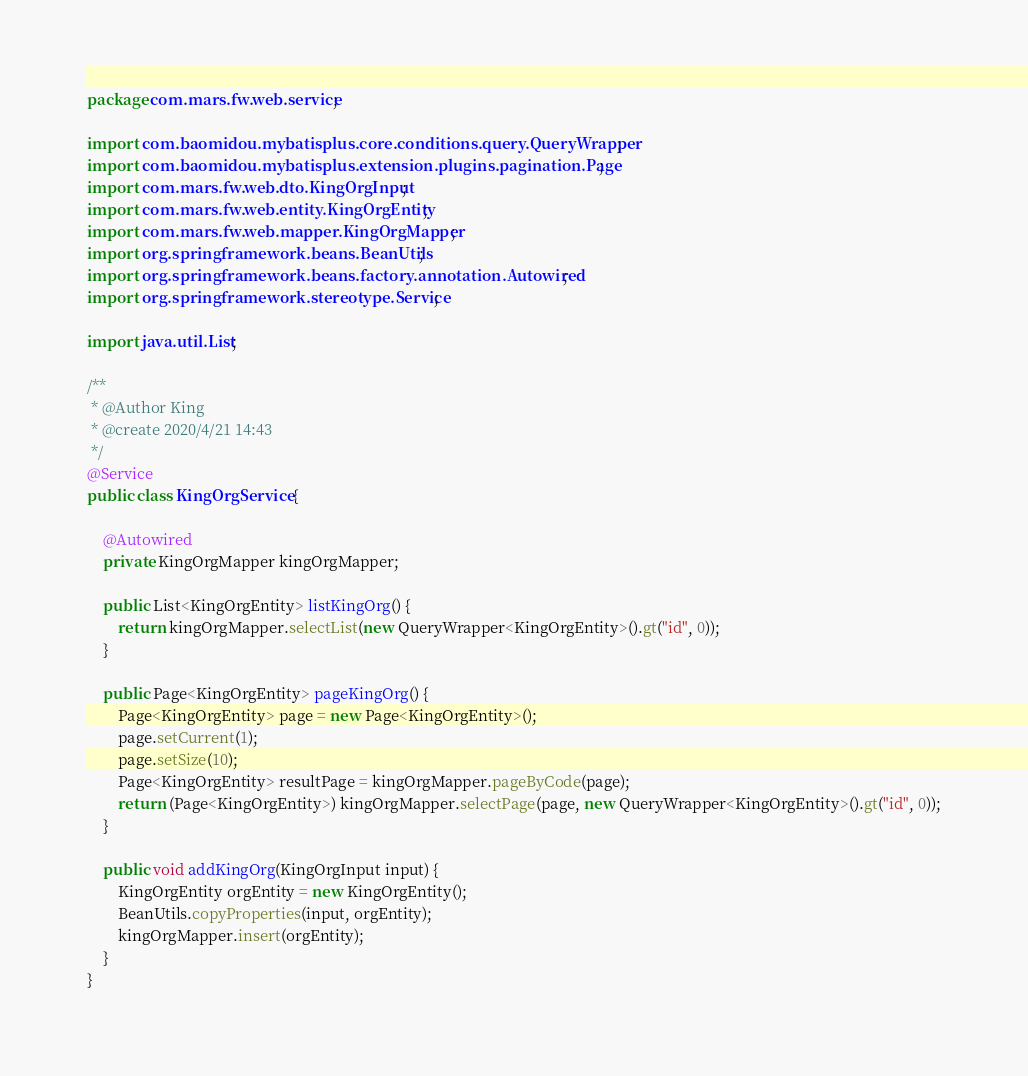Convert code to text. <code><loc_0><loc_0><loc_500><loc_500><_Java_>package com.mars.fw.web.service;

import com.baomidou.mybatisplus.core.conditions.query.QueryWrapper;
import com.baomidou.mybatisplus.extension.plugins.pagination.Page;
import com.mars.fw.web.dto.KingOrgInput;
import com.mars.fw.web.entity.KingOrgEntity;
import com.mars.fw.web.mapper.KingOrgMapper;
import org.springframework.beans.BeanUtils;
import org.springframework.beans.factory.annotation.Autowired;
import org.springframework.stereotype.Service;

import java.util.List;

/**
 * @Author King
 * @create 2020/4/21 14:43
 */
@Service
public class KingOrgService {

    @Autowired
    private KingOrgMapper kingOrgMapper;

    public List<KingOrgEntity> listKingOrg() {
        return kingOrgMapper.selectList(new QueryWrapper<KingOrgEntity>().gt("id", 0));
    }

    public Page<KingOrgEntity> pageKingOrg() {
        Page<KingOrgEntity> page = new Page<KingOrgEntity>();
        page.setCurrent(1);
        page.setSize(10);
        Page<KingOrgEntity> resultPage = kingOrgMapper.pageByCode(page);
        return (Page<KingOrgEntity>) kingOrgMapper.selectPage(page, new QueryWrapper<KingOrgEntity>().gt("id", 0));
    }

    public void addKingOrg(KingOrgInput input) {
        KingOrgEntity orgEntity = new KingOrgEntity();
        BeanUtils.copyProperties(input, orgEntity);
        kingOrgMapper.insert(orgEntity);
    }
}
</code> 